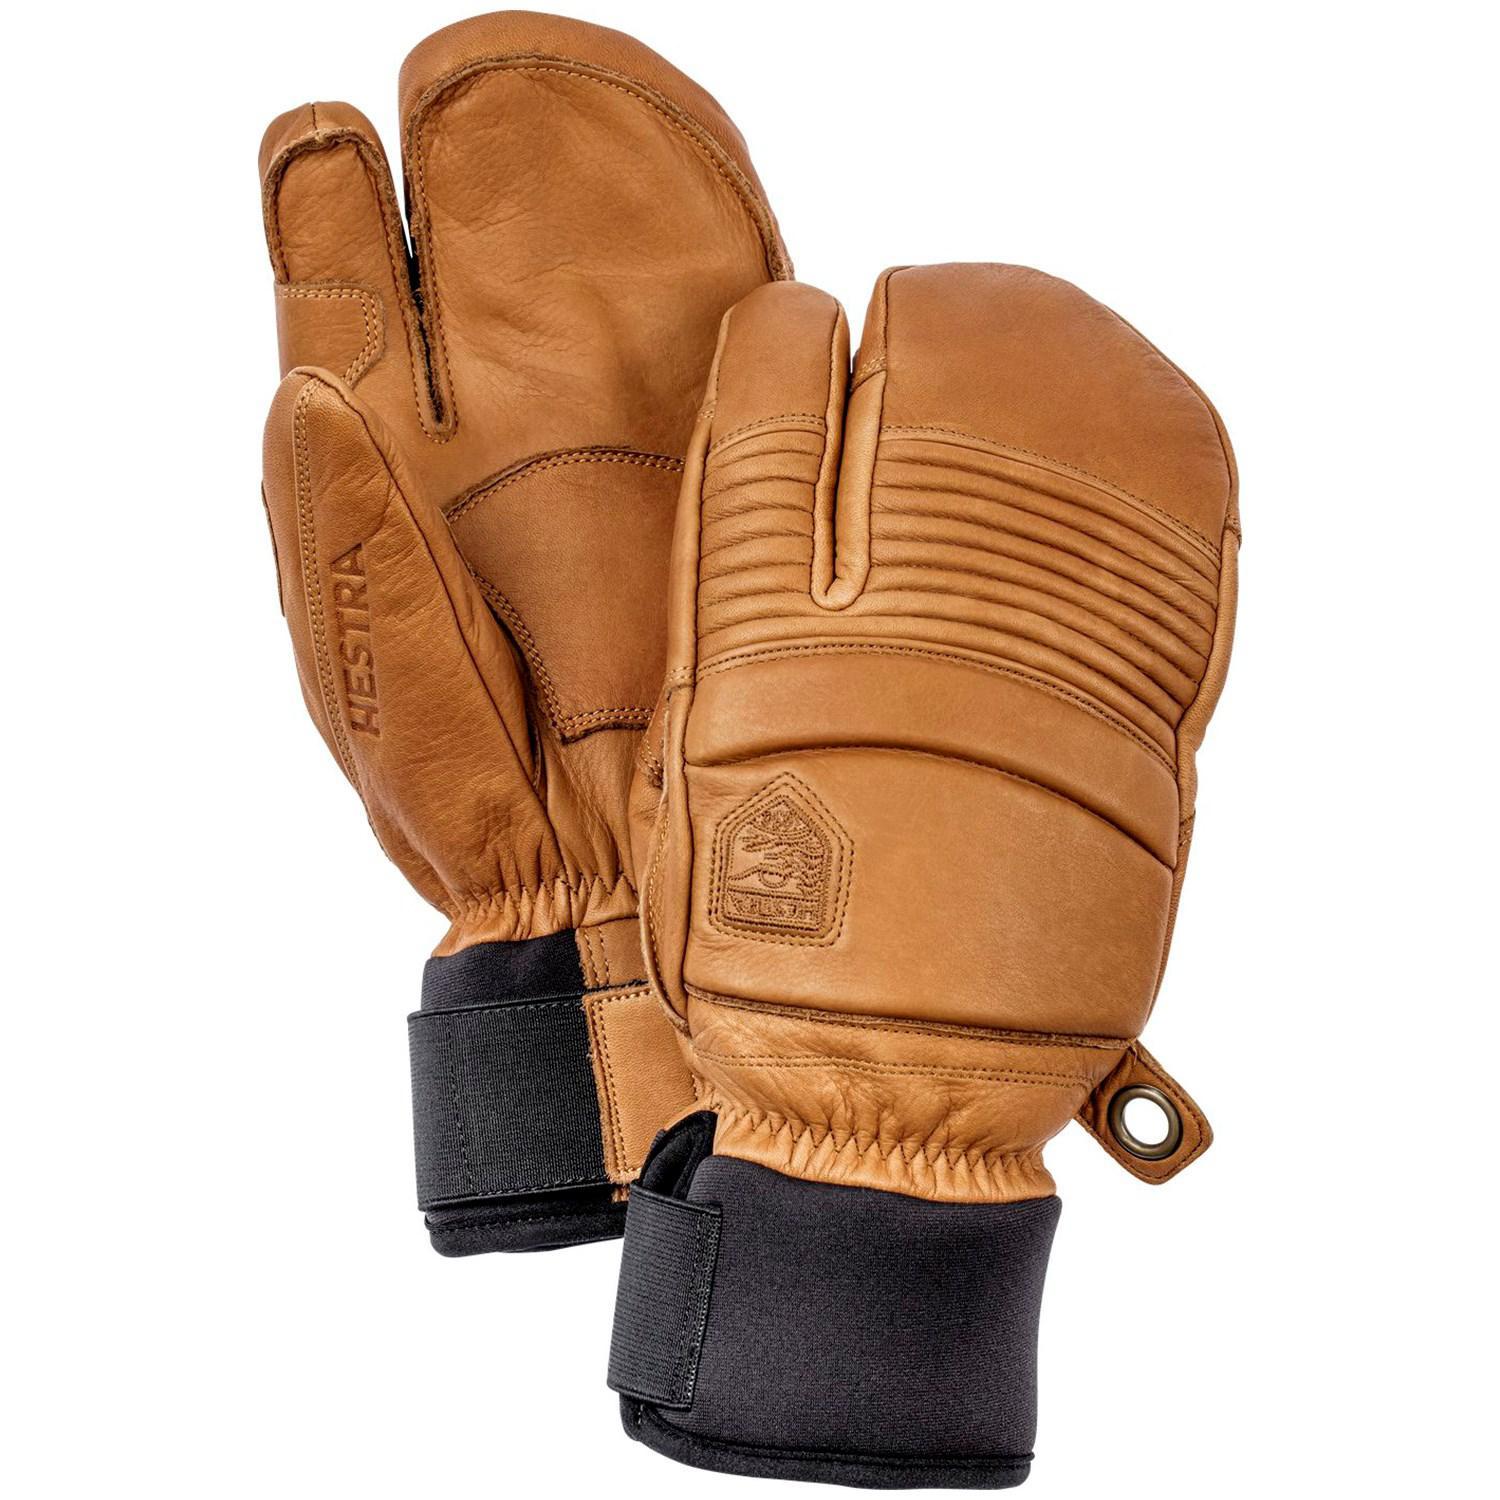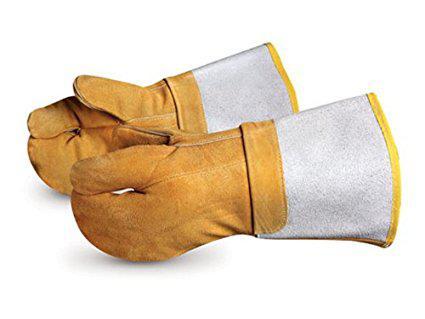The first image is the image on the left, the second image is the image on the right. Assess this claim about the two images: "Someone is wearing one of the gloves.". Correct or not? Answer yes or no. No. The first image is the image on the left, the second image is the image on the right. For the images shown, is this caption "In one image a pair of yellow-gold gloves are shown, the back view of one and the front view of the other, while the second image shows at least one similar glove with a human arm extended." true? Answer yes or no. No. 